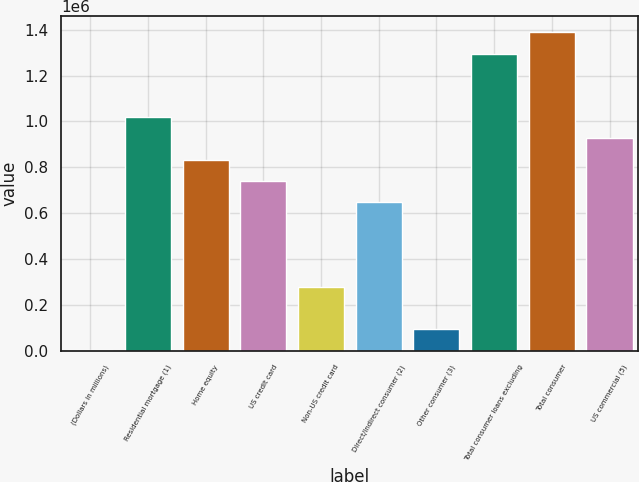Convert chart to OTSL. <chart><loc_0><loc_0><loc_500><loc_500><bar_chart><fcel>(Dollars in millions)<fcel>Residential mortgage (1)<fcel>Home equity<fcel>US credit card<fcel>Non-US credit card<fcel>Direct/Indirect consumer (2)<fcel>Other consumer (3)<fcel>Total consumer loans excluding<fcel>Total consumer<fcel>US commercial (5)<nl><fcel>2011<fcel>1.01862e+06<fcel>833781<fcel>741362<fcel>279268<fcel>648943<fcel>94429.9<fcel>1.29588e+06<fcel>1.38829e+06<fcel>926200<nl></chart> 